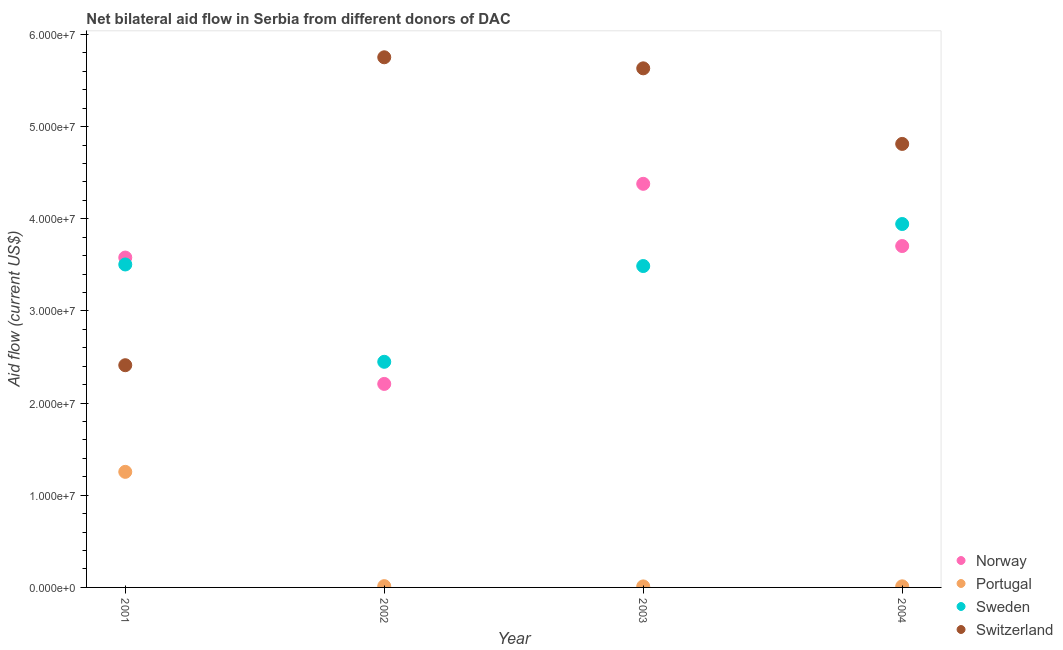How many different coloured dotlines are there?
Your response must be concise. 4. Is the number of dotlines equal to the number of legend labels?
Offer a very short reply. Yes. What is the amount of aid given by sweden in 2002?
Offer a very short reply. 2.45e+07. Across all years, what is the maximum amount of aid given by norway?
Offer a terse response. 4.38e+07. Across all years, what is the minimum amount of aid given by portugal?
Your answer should be compact. 1.10e+05. In which year was the amount of aid given by switzerland maximum?
Keep it short and to the point. 2002. In which year was the amount of aid given by sweden minimum?
Provide a succinct answer. 2002. What is the total amount of aid given by sweden in the graph?
Ensure brevity in your answer.  1.34e+08. What is the difference between the amount of aid given by switzerland in 2002 and that in 2003?
Offer a terse response. 1.20e+06. What is the difference between the amount of aid given by switzerland in 2003 and the amount of aid given by portugal in 2004?
Your answer should be compact. 5.62e+07. What is the average amount of aid given by switzerland per year?
Make the answer very short. 4.65e+07. In the year 2003, what is the difference between the amount of aid given by norway and amount of aid given by sweden?
Offer a very short reply. 8.92e+06. What is the ratio of the amount of aid given by norway in 2001 to that in 2004?
Ensure brevity in your answer.  0.97. Is the amount of aid given by norway in 2003 less than that in 2004?
Make the answer very short. No. Is the difference between the amount of aid given by norway in 2002 and 2003 greater than the difference between the amount of aid given by portugal in 2002 and 2003?
Provide a short and direct response. No. What is the difference between the highest and the second highest amount of aid given by portugal?
Give a very brief answer. 1.24e+07. What is the difference between the highest and the lowest amount of aid given by norway?
Provide a succinct answer. 2.17e+07. In how many years, is the amount of aid given by norway greater than the average amount of aid given by norway taken over all years?
Your answer should be very brief. 3. Does the amount of aid given by portugal monotonically increase over the years?
Ensure brevity in your answer.  No. Is the amount of aid given by switzerland strictly greater than the amount of aid given by portugal over the years?
Ensure brevity in your answer.  Yes. How many dotlines are there?
Make the answer very short. 4. Does the graph contain grids?
Your answer should be very brief. No. How are the legend labels stacked?
Offer a very short reply. Vertical. What is the title of the graph?
Keep it short and to the point. Net bilateral aid flow in Serbia from different donors of DAC. What is the label or title of the X-axis?
Offer a terse response. Year. What is the Aid flow (current US$) of Norway in 2001?
Provide a short and direct response. 3.58e+07. What is the Aid flow (current US$) in Portugal in 2001?
Your answer should be compact. 1.25e+07. What is the Aid flow (current US$) of Sweden in 2001?
Provide a succinct answer. 3.50e+07. What is the Aid flow (current US$) of Switzerland in 2001?
Ensure brevity in your answer.  2.41e+07. What is the Aid flow (current US$) in Norway in 2002?
Your answer should be compact. 2.21e+07. What is the Aid flow (current US$) in Sweden in 2002?
Ensure brevity in your answer.  2.45e+07. What is the Aid flow (current US$) in Switzerland in 2002?
Provide a short and direct response. 5.75e+07. What is the Aid flow (current US$) in Norway in 2003?
Provide a short and direct response. 4.38e+07. What is the Aid flow (current US$) in Sweden in 2003?
Keep it short and to the point. 3.49e+07. What is the Aid flow (current US$) in Switzerland in 2003?
Your response must be concise. 5.63e+07. What is the Aid flow (current US$) in Norway in 2004?
Your answer should be very brief. 3.70e+07. What is the Aid flow (current US$) in Sweden in 2004?
Keep it short and to the point. 3.94e+07. What is the Aid flow (current US$) of Switzerland in 2004?
Offer a terse response. 4.81e+07. Across all years, what is the maximum Aid flow (current US$) in Norway?
Provide a short and direct response. 4.38e+07. Across all years, what is the maximum Aid flow (current US$) of Portugal?
Make the answer very short. 1.25e+07. Across all years, what is the maximum Aid flow (current US$) of Sweden?
Give a very brief answer. 3.94e+07. Across all years, what is the maximum Aid flow (current US$) in Switzerland?
Provide a short and direct response. 5.75e+07. Across all years, what is the minimum Aid flow (current US$) of Norway?
Your answer should be very brief. 2.21e+07. Across all years, what is the minimum Aid flow (current US$) in Sweden?
Your answer should be very brief. 2.45e+07. Across all years, what is the minimum Aid flow (current US$) in Switzerland?
Ensure brevity in your answer.  2.41e+07. What is the total Aid flow (current US$) in Norway in the graph?
Ensure brevity in your answer.  1.39e+08. What is the total Aid flow (current US$) of Portugal in the graph?
Offer a terse response. 1.29e+07. What is the total Aid flow (current US$) in Sweden in the graph?
Give a very brief answer. 1.34e+08. What is the total Aid flow (current US$) of Switzerland in the graph?
Your response must be concise. 1.86e+08. What is the difference between the Aid flow (current US$) in Norway in 2001 and that in 2002?
Give a very brief answer. 1.37e+07. What is the difference between the Aid flow (current US$) in Portugal in 2001 and that in 2002?
Give a very brief answer. 1.24e+07. What is the difference between the Aid flow (current US$) in Sweden in 2001 and that in 2002?
Your response must be concise. 1.06e+07. What is the difference between the Aid flow (current US$) in Switzerland in 2001 and that in 2002?
Provide a succinct answer. -3.34e+07. What is the difference between the Aid flow (current US$) of Norway in 2001 and that in 2003?
Give a very brief answer. -8.00e+06. What is the difference between the Aid flow (current US$) of Portugal in 2001 and that in 2003?
Offer a very short reply. 1.24e+07. What is the difference between the Aid flow (current US$) of Switzerland in 2001 and that in 2003?
Your response must be concise. -3.22e+07. What is the difference between the Aid flow (current US$) of Norway in 2001 and that in 2004?
Your answer should be very brief. -1.25e+06. What is the difference between the Aid flow (current US$) in Portugal in 2001 and that in 2004?
Your answer should be compact. 1.24e+07. What is the difference between the Aid flow (current US$) in Sweden in 2001 and that in 2004?
Your answer should be very brief. -4.39e+06. What is the difference between the Aid flow (current US$) in Switzerland in 2001 and that in 2004?
Provide a succinct answer. -2.40e+07. What is the difference between the Aid flow (current US$) in Norway in 2002 and that in 2003?
Provide a succinct answer. -2.17e+07. What is the difference between the Aid flow (current US$) in Portugal in 2002 and that in 2003?
Offer a terse response. 3.00e+04. What is the difference between the Aid flow (current US$) of Sweden in 2002 and that in 2003?
Provide a short and direct response. -1.04e+07. What is the difference between the Aid flow (current US$) of Switzerland in 2002 and that in 2003?
Make the answer very short. 1.20e+06. What is the difference between the Aid flow (current US$) in Norway in 2002 and that in 2004?
Your response must be concise. -1.50e+07. What is the difference between the Aid flow (current US$) in Portugal in 2002 and that in 2004?
Keep it short and to the point. 2.00e+04. What is the difference between the Aid flow (current US$) in Sweden in 2002 and that in 2004?
Offer a very short reply. -1.50e+07. What is the difference between the Aid flow (current US$) of Switzerland in 2002 and that in 2004?
Keep it short and to the point. 9.40e+06. What is the difference between the Aid flow (current US$) of Norway in 2003 and that in 2004?
Ensure brevity in your answer.  6.75e+06. What is the difference between the Aid flow (current US$) of Portugal in 2003 and that in 2004?
Make the answer very short. -10000. What is the difference between the Aid flow (current US$) in Sweden in 2003 and that in 2004?
Your answer should be very brief. -4.56e+06. What is the difference between the Aid flow (current US$) of Switzerland in 2003 and that in 2004?
Provide a succinct answer. 8.20e+06. What is the difference between the Aid flow (current US$) of Norway in 2001 and the Aid flow (current US$) of Portugal in 2002?
Your answer should be compact. 3.56e+07. What is the difference between the Aid flow (current US$) of Norway in 2001 and the Aid flow (current US$) of Sweden in 2002?
Keep it short and to the point. 1.13e+07. What is the difference between the Aid flow (current US$) of Norway in 2001 and the Aid flow (current US$) of Switzerland in 2002?
Your response must be concise. -2.17e+07. What is the difference between the Aid flow (current US$) in Portugal in 2001 and the Aid flow (current US$) in Sweden in 2002?
Ensure brevity in your answer.  -1.19e+07. What is the difference between the Aid flow (current US$) of Portugal in 2001 and the Aid flow (current US$) of Switzerland in 2002?
Provide a succinct answer. -4.50e+07. What is the difference between the Aid flow (current US$) in Sweden in 2001 and the Aid flow (current US$) in Switzerland in 2002?
Your response must be concise. -2.25e+07. What is the difference between the Aid flow (current US$) in Norway in 2001 and the Aid flow (current US$) in Portugal in 2003?
Give a very brief answer. 3.57e+07. What is the difference between the Aid flow (current US$) in Norway in 2001 and the Aid flow (current US$) in Sweden in 2003?
Your answer should be compact. 9.20e+05. What is the difference between the Aid flow (current US$) in Norway in 2001 and the Aid flow (current US$) in Switzerland in 2003?
Your response must be concise. -2.05e+07. What is the difference between the Aid flow (current US$) in Portugal in 2001 and the Aid flow (current US$) in Sweden in 2003?
Provide a succinct answer. -2.23e+07. What is the difference between the Aid flow (current US$) in Portugal in 2001 and the Aid flow (current US$) in Switzerland in 2003?
Offer a terse response. -4.38e+07. What is the difference between the Aid flow (current US$) in Sweden in 2001 and the Aid flow (current US$) in Switzerland in 2003?
Your answer should be very brief. -2.13e+07. What is the difference between the Aid flow (current US$) of Norway in 2001 and the Aid flow (current US$) of Portugal in 2004?
Keep it short and to the point. 3.57e+07. What is the difference between the Aid flow (current US$) of Norway in 2001 and the Aid flow (current US$) of Sweden in 2004?
Offer a very short reply. -3.64e+06. What is the difference between the Aid flow (current US$) of Norway in 2001 and the Aid flow (current US$) of Switzerland in 2004?
Your answer should be compact. -1.23e+07. What is the difference between the Aid flow (current US$) of Portugal in 2001 and the Aid flow (current US$) of Sweden in 2004?
Provide a succinct answer. -2.69e+07. What is the difference between the Aid flow (current US$) of Portugal in 2001 and the Aid flow (current US$) of Switzerland in 2004?
Ensure brevity in your answer.  -3.56e+07. What is the difference between the Aid flow (current US$) in Sweden in 2001 and the Aid flow (current US$) in Switzerland in 2004?
Provide a succinct answer. -1.31e+07. What is the difference between the Aid flow (current US$) of Norway in 2002 and the Aid flow (current US$) of Portugal in 2003?
Offer a terse response. 2.20e+07. What is the difference between the Aid flow (current US$) of Norway in 2002 and the Aid flow (current US$) of Sweden in 2003?
Your response must be concise. -1.28e+07. What is the difference between the Aid flow (current US$) of Norway in 2002 and the Aid flow (current US$) of Switzerland in 2003?
Your answer should be compact. -3.42e+07. What is the difference between the Aid flow (current US$) in Portugal in 2002 and the Aid flow (current US$) in Sweden in 2003?
Provide a succinct answer. -3.47e+07. What is the difference between the Aid flow (current US$) of Portugal in 2002 and the Aid flow (current US$) of Switzerland in 2003?
Your answer should be compact. -5.62e+07. What is the difference between the Aid flow (current US$) of Sweden in 2002 and the Aid flow (current US$) of Switzerland in 2003?
Your answer should be very brief. -3.18e+07. What is the difference between the Aid flow (current US$) in Norway in 2002 and the Aid flow (current US$) in Portugal in 2004?
Make the answer very short. 2.20e+07. What is the difference between the Aid flow (current US$) in Norway in 2002 and the Aid flow (current US$) in Sweden in 2004?
Make the answer very short. -1.74e+07. What is the difference between the Aid flow (current US$) of Norway in 2002 and the Aid flow (current US$) of Switzerland in 2004?
Offer a terse response. -2.60e+07. What is the difference between the Aid flow (current US$) of Portugal in 2002 and the Aid flow (current US$) of Sweden in 2004?
Keep it short and to the point. -3.93e+07. What is the difference between the Aid flow (current US$) in Portugal in 2002 and the Aid flow (current US$) in Switzerland in 2004?
Your response must be concise. -4.80e+07. What is the difference between the Aid flow (current US$) in Sweden in 2002 and the Aid flow (current US$) in Switzerland in 2004?
Your answer should be very brief. -2.36e+07. What is the difference between the Aid flow (current US$) of Norway in 2003 and the Aid flow (current US$) of Portugal in 2004?
Offer a terse response. 4.37e+07. What is the difference between the Aid flow (current US$) of Norway in 2003 and the Aid flow (current US$) of Sweden in 2004?
Make the answer very short. 4.36e+06. What is the difference between the Aid flow (current US$) in Norway in 2003 and the Aid flow (current US$) in Switzerland in 2004?
Provide a succinct answer. -4.33e+06. What is the difference between the Aid flow (current US$) of Portugal in 2003 and the Aid flow (current US$) of Sweden in 2004?
Make the answer very short. -3.93e+07. What is the difference between the Aid flow (current US$) in Portugal in 2003 and the Aid flow (current US$) in Switzerland in 2004?
Make the answer very short. -4.80e+07. What is the difference between the Aid flow (current US$) in Sweden in 2003 and the Aid flow (current US$) in Switzerland in 2004?
Make the answer very short. -1.32e+07. What is the average Aid flow (current US$) of Norway per year?
Provide a succinct answer. 3.47e+07. What is the average Aid flow (current US$) in Portugal per year?
Your answer should be compact. 3.23e+06. What is the average Aid flow (current US$) in Sweden per year?
Ensure brevity in your answer.  3.35e+07. What is the average Aid flow (current US$) of Switzerland per year?
Provide a short and direct response. 4.65e+07. In the year 2001, what is the difference between the Aid flow (current US$) in Norway and Aid flow (current US$) in Portugal?
Your response must be concise. 2.32e+07. In the year 2001, what is the difference between the Aid flow (current US$) in Norway and Aid flow (current US$) in Sweden?
Offer a terse response. 7.50e+05. In the year 2001, what is the difference between the Aid flow (current US$) of Norway and Aid flow (current US$) of Switzerland?
Make the answer very short. 1.17e+07. In the year 2001, what is the difference between the Aid flow (current US$) in Portugal and Aid flow (current US$) in Sweden?
Provide a short and direct response. -2.25e+07. In the year 2001, what is the difference between the Aid flow (current US$) of Portugal and Aid flow (current US$) of Switzerland?
Provide a succinct answer. -1.16e+07. In the year 2001, what is the difference between the Aid flow (current US$) of Sweden and Aid flow (current US$) of Switzerland?
Provide a short and direct response. 1.09e+07. In the year 2002, what is the difference between the Aid flow (current US$) in Norway and Aid flow (current US$) in Portugal?
Keep it short and to the point. 2.19e+07. In the year 2002, what is the difference between the Aid flow (current US$) in Norway and Aid flow (current US$) in Sweden?
Keep it short and to the point. -2.40e+06. In the year 2002, what is the difference between the Aid flow (current US$) in Norway and Aid flow (current US$) in Switzerland?
Make the answer very short. -3.54e+07. In the year 2002, what is the difference between the Aid flow (current US$) in Portugal and Aid flow (current US$) in Sweden?
Make the answer very short. -2.43e+07. In the year 2002, what is the difference between the Aid flow (current US$) in Portugal and Aid flow (current US$) in Switzerland?
Your answer should be compact. -5.74e+07. In the year 2002, what is the difference between the Aid flow (current US$) of Sweden and Aid flow (current US$) of Switzerland?
Your answer should be very brief. -3.30e+07. In the year 2003, what is the difference between the Aid flow (current US$) in Norway and Aid flow (current US$) in Portugal?
Your response must be concise. 4.37e+07. In the year 2003, what is the difference between the Aid flow (current US$) of Norway and Aid flow (current US$) of Sweden?
Provide a succinct answer. 8.92e+06. In the year 2003, what is the difference between the Aid flow (current US$) of Norway and Aid flow (current US$) of Switzerland?
Provide a short and direct response. -1.25e+07. In the year 2003, what is the difference between the Aid flow (current US$) of Portugal and Aid flow (current US$) of Sweden?
Provide a succinct answer. -3.48e+07. In the year 2003, what is the difference between the Aid flow (current US$) in Portugal and Aid flow (current US$) in Switzerland?
Your response must be concise. -5.62e+07. In the year 2003, what is the difference between the Aid flow (current US$) of Sweden and Aid flow (current US$) of Switzerland?
Ensure brevity in your answer.  -2.14e+07. In the year 2004, what is the difference between the Aid flow (current US$) of Norway and Aid flow (current US$) of Portugal?
Provide a succinct answer. 3.69e+07. In the year 2004, what is the difference between the Aid flow (current US$) of Norway and Aid flow (current US$) of Sweden?
Offer a terse response. -2.39e+06. In the year 2004, what is the difference between the Aid flow (current US$) in Norway and Aid flow (current US$) in Switzerland?
Provide a succinct answer. -1.11e+07. In the year 2004, what is the difference between the Aid flow (current US$) in Portugal and Aid flow (current US$) in Sweden?
Make the answer very short. -3.93e+07. In the year 2004, what is the difference between the Aid flow (current US$) of Portugal and Aid flow (current US$) of Switzerland?
Offer a terse response. -4.80e+07. In the year 2004, what is the difference between the Aid flow (current US$) of Sweden and Aid flow (current US$) of Switzerland?
Provide a succinct answer. -8.69e+06. What is the ratio of the Aid flow (current US$) of Norway in 2001 to that in 2002?
Offer a terse response. 1.62. What is the ratio of the Aid flow (current US$) in Portugal in 2001 to that in 2002?
Keep it short and to the point. 89.57. What is the ratio of the Aid flow (current US$) in Sweden in 2001 to that in 2002?
Offer a terse response. 1.43. What is the ratio of the Aid flow (current US$) of Switzerland in 2001 to that in 2002?
Make the answer very short. 0.42. What is the ratio of the Aid flow (current US$) of Norway in 2001 to that in 2003?
Your response must be concise. 0.82. What is the ratio of the Aid flow (current US$) of Portugal in 2001 to that in 2003?
Provide a succinct answer. 114. What is the ratio of the Aid flow (current US$) of Switzerland in 2001 to that in 2003?
Offer a very short reply. 0.43. What is the ratio of the Aid flow (current US$) in Norway in 2001 to that in 2004?
Your answer should be compact. 0.97. What is the ratio of the Aid flow (current US$) in Portugal in 2001 to that in 2004?
Offer a very short reply. 104.5. What is the ratio of the Aid flow (current US$) of Sweden in 2001 to that in 2004?
Keep it short and to the point. 0.89. What is the ratio of the Aid flow (current US$) in Switzerland in 2001 to that in 2004?
Provide a succinct answer. 0.5. What is the ratio of the Aid flow (current US$) in Norway in 2002 to that in 2003?
Offer a terse response. 0.5. What is the ratio of the Aid flow (current US$) of Portugal in 2002 to that in 2003?
Your response must be concise. 1.27. What is the ratio of the Aid flow (current US$) of Sweden in 2002 to that in 2003?
Provide a short and direct response. 0.7. What is the ratio of the Aid flow (current US$) of Switzerland in 2002 to that in 2003?
Your response must be concise. 1.02. What is the ratio of the Aid flow (current US$) of Norway in 2002 to that in 2004?
Provide a short and direct response. 0.6. What is the ratio of the Aid flow (current US$) of Sweden in 2002 to that in 2004?
Make the answer very short. 0.62. What is the ratio of the Aid flow (current US$) in Switzerland in 2002 to that in 2004?
Provide a short and direct response. 1.2. What is the ratio of the Aid flow (current US$) in Norway in 2003 to that in 2004?
Give a very brief answer. 1.18. What is the ratio of the Aid flow (current US$) of Portugal in 2003 to that in 2004?
Ensure brevity in your answer.  0.92. What is the ratio of the Aid flow (current US$) of Sweden in 2003 to that in 2004?
Make the answer very short. 0.88. What is the ratio of the Aid flow (current US$) of Switzerland in 2003 to that in 2004?
Keep it short and to the point. 1.17. What is the difference between the highest and the second highest Aid flow (current US$) in Norway?
Offer a terse response. 6.75e+06. What is the difference between the highest and the second highest Aid flow (current US$) of Portugal?
Make the answer very short. 1.24e+07. What is the difference between the highest and the second highest Aid flow (current US$) of Sweden?
Make the answer very short. 4.39e+06. What is the difference between the highest and the second highest Aid flow (current US$) in Switzerland?
Offer a very short reply. 1.20e+06. What is the difference between the highest and the lowest Aid flow (current US$) of Norway?
Offer a very short reply. 2.17e+07. What is the difference between the highest and the lowest Aid flow (current US$) of Portugal?
Make the answer very short. 1.24e+07. What is the difference between the highest and the lowest Aid flow (current US$) in Sweden?
Ensure brevity in your answer.  1.50e+07. What is the difference between the highest and the lowest Aid flow (current US$) in Switzerland?
Your response must be concise. 3.34e+07. 